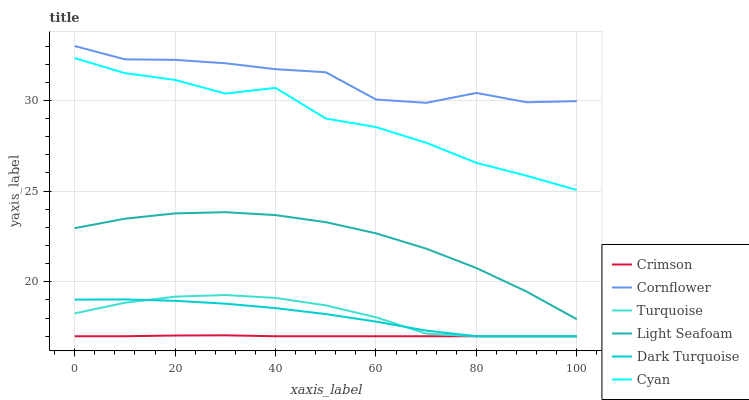Does Turquoise have the minimum area under the curve?
Answer yes or no. No. Does Turquoise have the maximum area under the curve?
Answer yes or no. No. Is Turquoise the smoothest?
Answer yes or no. No. Is Turquoise the roughest?
Answer yes or no. No. Does Cyan have the lowest value?
Answer yes or no. No. Does Turquoise have the highest value?
Answer yes or no. No. Is Cyan less than Cornflower?
Answer yes or no. Yes. Is Cornflower greater than Dark Turquoise?
Answer yes or no. Yes. Does Cyan intersect Cornflower?
Answer yes or no. No. 